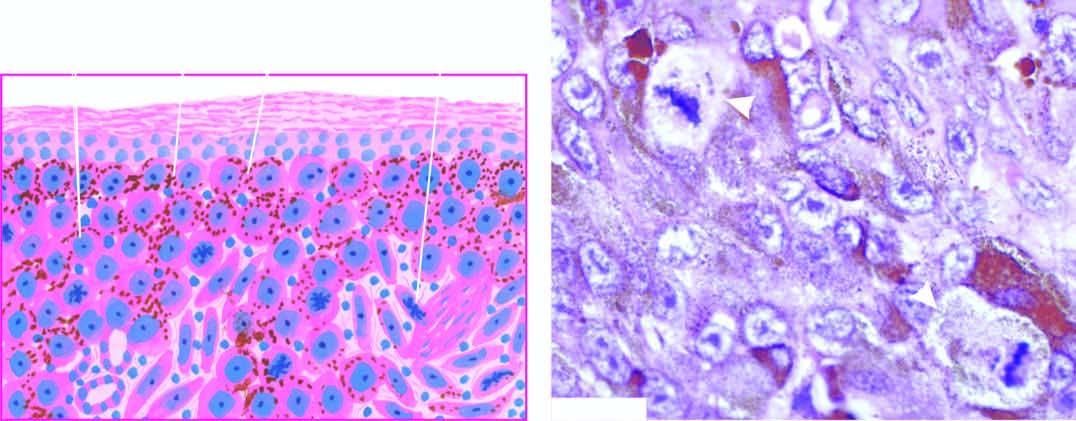does alignant melanoma show junctional activity at the dermal-epidermal junction?
Answer the question using a single word or phrase. Yes 